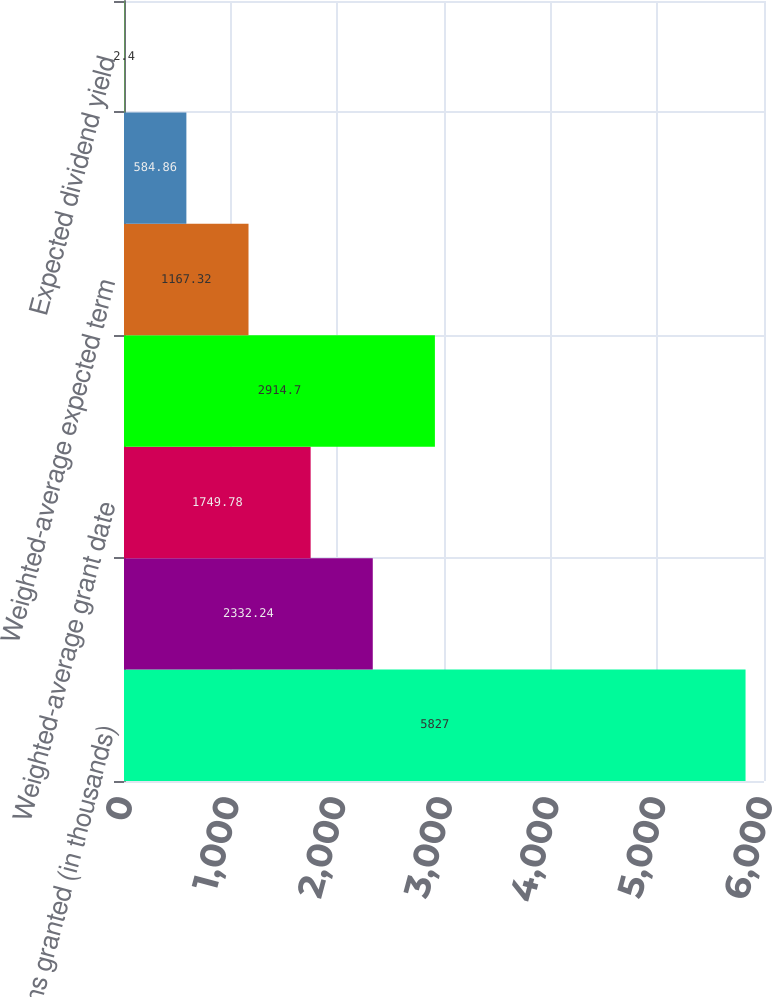<chart> <loc_0><loc_0><loc_500><loc_500><bar_chart><fcel>Options granted (in thousands)<fcel>Weighted-average exercise<fcel>Weighted-average grant date<fcel>Weighted-average expected<fcel>Weighted-average expected term<fcel>Risk-free interest rate<fcel>Expected dividend yield<nl><fcel>5827<fcel>2332.24<fcel>1749.78<fcel>2914.7<fcel>1167.32<fcel>584.86<fcel>2.4<nl></chart> 